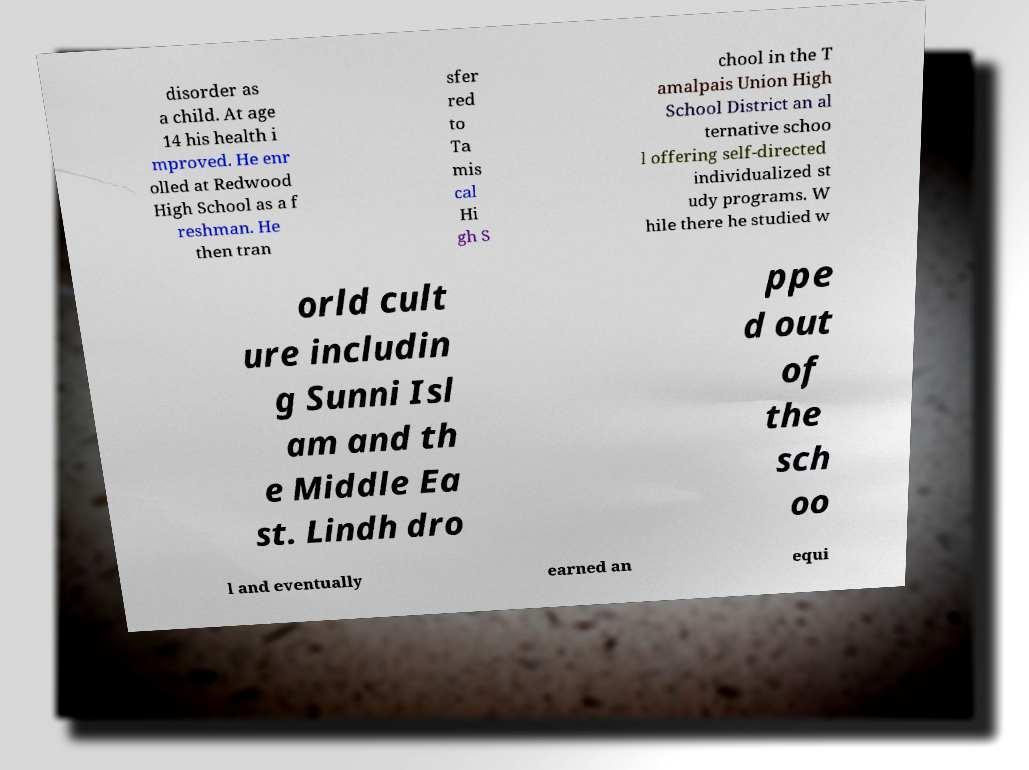Please identify and transcribe the text found in this image. disorder as a child. At age 14 his health i mproved. He enr olled at Redwood High School as a f reshman. He then tran sfer red to Ta mis cal Hi gh S chool in the T amalpais Union High School District an al ternative schoo l offering self-directed individualized st udy programs. W hile there he studied w orld cult ure includin g Sunni Isl am and th e Middle Ea st. Lindh dro ppe d out of the sch oo l and eventually earned an equi 